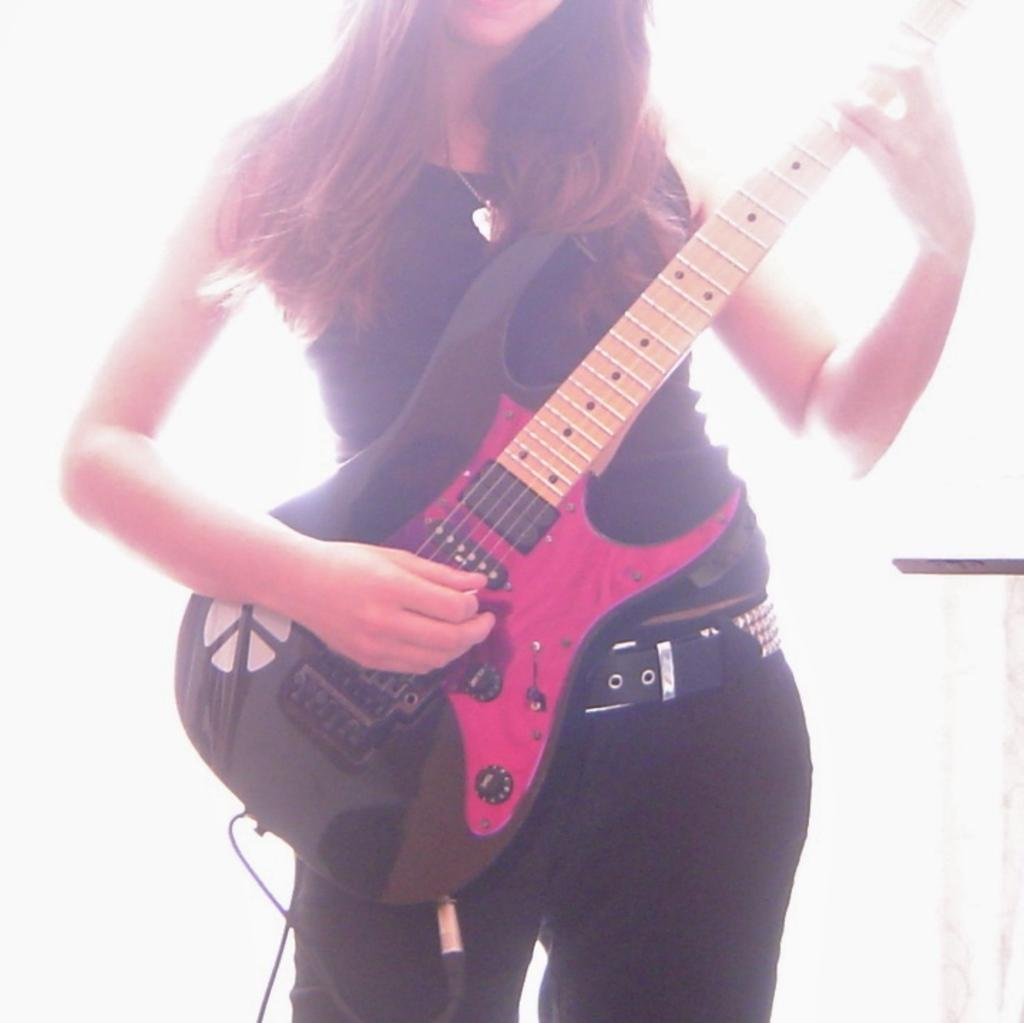Who is the main subject in the image? There is a woman in the image. What is the woman doing in the image? The woman is standing and playing a guitar. What type of feast is being prepared by the woman in the image? There is no indication of a feast or any food preparation in the image; the woman is playing a guitar. Can you see any wounds on the woman in the image? There is no mention of any wounds or injuries on the woman in the image; she is simply playing a guitar. 